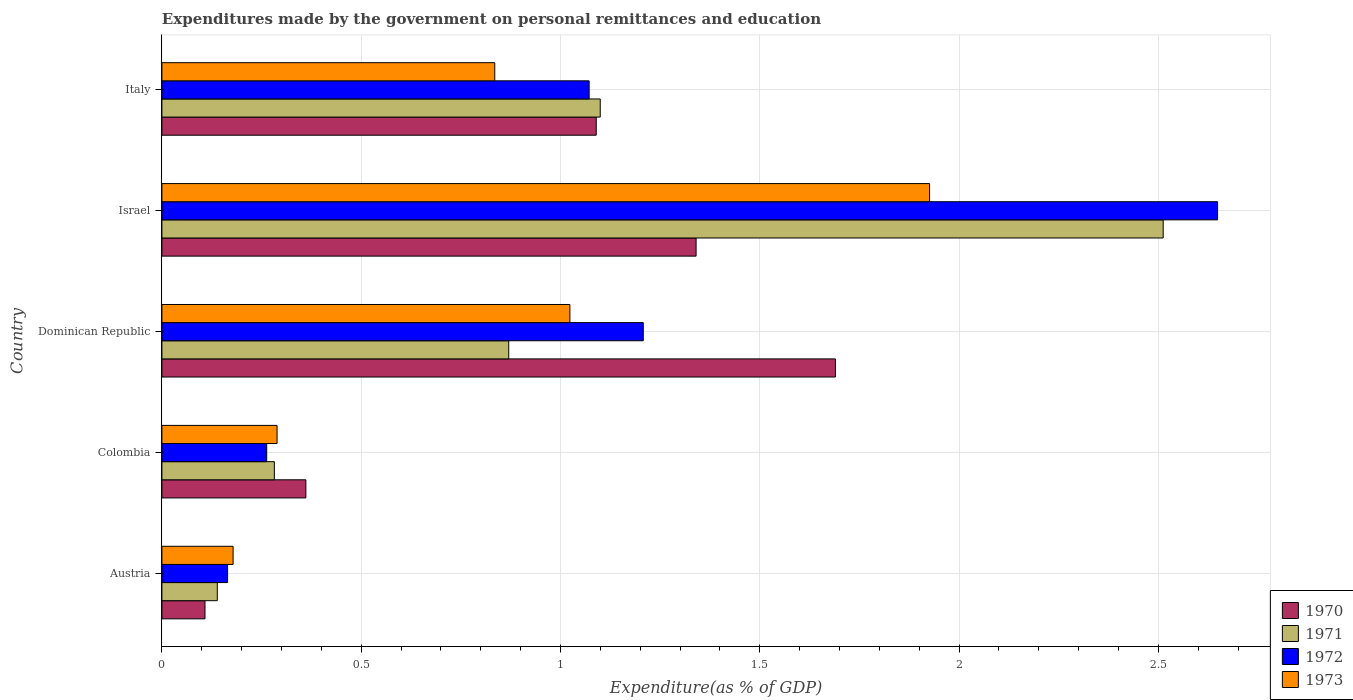How many different coloured bars are there?
Provide a short and direct response. 4. Are the number of bars on each tick of the Y-axis equal?
Keep it short and to the point. Yes. How many bars are there on the 1st tick from the bottom?
Offer a terse response. 4. What is the label of the 1st group of bars from the top?
Your response must be concise. Italy. In how many cases, is the number of bars for a given country not equal to the number of legend labels?
Offer a very short reply. 0. What is the expenditures made by the government on personal remittances and education in 1971 in Dominican Republic?
Give a very brief answer. 0.87. Across all countries, what is the maximum expenditures made by the government on personal remittances and education in 1973?
Make the answer very short. 1.93. Across all countries, what is the minimum expenditures made by the government on personal remittances and education in 1972?
Provide a succinct answer. 0.16. In which country was the expenditures made by the government on personal remittances and education in 1970 minimum?
Provide a succinct answer. Austria. What is the total expenditures made by the government on personal remittances and education in 1973 in the graph?
Offer a terse response. 4.25. What is the difference between the expenditures made by the government on personal remittances and education in 1972 in Colombia and that in Dominican Republic?
Your response must be concise. -0.94. What is the difference between the expenditures made by the government on personal remittances and education in 1972 in Italy and the expenditures made by the government on personal remittances and education in 1973 in Austria?
Offer a terse response. 0.89. What is the average expenditures made by the government on personal remittances and education in 1972 per country?
Make the answer very short. 1.07. What is the difference between the expenditures made by the government on personal remittances and education in 1971 and expenditures made by the government on personal remittances and education in 1972 in Austria?
Offer a terse response. -0.03. What is the ratio of the expenditures made by the government on personal remittances and education in 1973 in Colombia to that in Dominican Republic?
Offer a very short reply. 0.28. Is the difference between the expenditures made by the government on personal remittances and education in 1971 in Austria and Israel greater than the difference between the expenditures made by the government on personal remittances and education in 1972 in Austria and Israel?
Ensure brevity in your answer.  Yes. What is the difference between the highest and the second highest expenditures made by the government on personal remittances and education in 1970?
Provide a succinct answer. 0.35. What is the difference between the highest and the lowest expenditures made by the government on personal remittances and education in 1971?
Give a very brief answer. 2.37. In how many countries, is the expenditures made by the government on personal remittances and education in 1973 greater than the average expenditures made by the government on personal remittances and education in 1973 taken over all countries?
Offer a terse response. 2. Is the sum of the expenditures made by the government on personal remittances and education in 1972 in Austria and Dominican Republic greater than the maximum expenditures made by the government on personal remittances and education in 1973 across all countries?
Your answer should be very brief. No. What does the 4th bar from the top in Austria represents?
Give a very brief answer. 1970. Is it the case that in every country, the sum of the expenditures made by the government on personal remittances and education in 1972 and expenditures made by the government on personal remittances and education in 1971 is greater than the expenditures made by the government on personal remittances and education in 1973?
Make the answer very short. Yes. How many bars are there?
Your answer should be compact. 20. What is the difference between two consecutive major ticks on the X-axis?
Keep it short and to the point. 0.5. Does the graph contain any zero values?
Ensure brevity in your answer.  No. Where does the legend appear in the graph?
Offer a very short reply. Bottom right. How are the legend labels stacked?
Your answer should be very brief. Vertical. What is the title of the graph?
Offer a very short reply. Expenditures made by the government on personal remittances and education. What is the label or title of the X-axis?
Provide a short and direct response. Expenditure(as % of GDP). What is the label or title of the Y-axis?
Provide a short and direct response. Country. What is the Expenditure(as % of GDP) of 1970 in Austria?
Offer a very short reply. 0.11. What is the Expenditure(as % of GDP) in 1971 in Austria?
Offer a very short reply. 0.14. What is the Expenditure(as % of GDP) in 1972 in Austria?
Offer a very short reply. 0.16. What is the Expenditure(as % of GDP) of 1973 in Austria?
Keep it short and to the point. 0.18. What is the Expenditure(as % of GDP) of 1970 in Colombia?
Ensure brevity in your answer.  0.36. What is the Expenditure(as % of GDP) in 1971 in Colombia?
Offer a very short reply. 0.28. What is the Expenditure(as % of GDP) in 1972 in Colombia?
Your answer should be very brief. 0.26. What is the Expenditure(as % of GDP) in 1973 in Colombia?
Your answer should be compact. 0.29. What is the Expenditure(as % of GDP) of 1970 in Dominican Republic?
Provide a succinct answer. 1.69. What is the Expenditure(as % of GDP) in 1971 in Dominican Republic?
Offer a terse response. 0.87. What is the Expenditure(as % of GDP) of 1972 in Dominican Republic?
Your answer should be very brief. 1.21. What is the Expenditure(as % of GDP) in 1973 in Dominican Republic?
Your answer should be compact. 1.02. What is the Expenditure(as % of GDP) of 1970 in Israel?
Ensure brevity in your answer.  1.34. What is the Expenditure(as % of GDP) of 1971 in Israel?
Make the answer very short. 2.51. What is the Expenditure(as % of GDP) in 1972 in Israel?
Offer a terse response. 2.65. What is the Expenditure(as % of GDP) in 1973 in Israel?
Ensure brevity in your answer.  1.93. What is the Expenditure(as % of GDP) in 1970 in Italy?
Give a very brief answer. 1.09. What is the Expenditure(as % of GDP) in 1971 in Italy?
Ensure brevity in your answer.  1.1. What is the Expenditure(as % of GDP) in 1972 in Italy?
Your response must be concise. 1.07. What is the Expenditure(as % of GDP) of 1973 in Italy?
Offer a terse response. 0.84. Across all countries, what is the maximum Expenditure(as % of GDP) of 1970?
Give a very brief answer. 1.69. Across all countries, what is the maximum Expenditure(as % of GDP) in 1971?
Provide a short and direct response. 2.51. Across all countries, what is the maximum Expenditure(as % of GDP) in 1972?
Your answer should be compact. 2.65. Across all countries, what is the maximum Expenditure(as % of GDP) of 1973?
Your response must be concise. 1.93. Across all countries, what is the minimum Expenditure(as % of GDP) in 1970?
Keep it short and to the point. 0.11. Across all countries, what is the minimum Expenditure(as % of GDP) of 1971?
Give a very brief answer. 0.14. Across all countries, what is the minimum Expenditure(as % of GDP) of 1972?
Offer a very short reply. 0.16. Across all countries, what is the minimum Expenditure(as % of GDP) of 1973?
Offer a very short reply. 0.18. What is the total Expenditure(as % of GDP) in 1970 in the graph?
Offer a terse response. 4.59. What is the total Expenditure(as % of GDP) in 1971 in the graph?
Offer a terse response. 4.9. What is the total Expenditure(as % of GDP) in 1972 in the graph?
Give a very brief answer. 5.36. What is the total Expenditure(as % of GDP) of 1973 in the graph?
Keep it short and to the point. 4.25. What is the difference between the Expenditure(as % of GDP) of 1970 in Austria and that in Colombia?
Your answer should be very brief. -0.25. What is the difference between the Expenditure(as % of GDP) in 1971 in Austria and that in Colombia?
Provide a short and direct response. -0.14. What is the difference between the Expenditure(as % of GDP) in 1972 in Austria and that in Colombia?
Keep it short and to the point. -0.1. What is the difference between the Expenditure(as % of GDP) of 1973 in Austria and that in Colombia?
Provide a succinct answer. -0.11. What is the difference between the Expenditure(as % of GDP) in 1970 in Austria and that in Dominican Republic?
Offer a terse response. -1.58. What is the difference between the Expenditure(as % of GDP) of 1971 in Austria and that in Dominican Republic?
Give a very brief answer. -0.73. What is the difference between the Expenditure(as % of GDP) of 1972 in Austria and that in Dominican Republic?
Keep it short and to the point. -1.04. What is the difference between the Expenditure(as % of GDP) of 1973 in Austria and that in Dominican Republic?
Your answer should be compact. -0.84. What is the difference between the Expenditure(as % of GDP) in 1970 in Austria and that in Israel?
Keep it short and to the point. -1.23. What is the difference between the Expenditure(as % of GDP) in 1971 in Austria and that in Israel?
Offer a terse response. -2.37. What is the difference between the Expenditure(as % of GDP) of 1972 in Austria and that in Israel?
Provide a short and direct response. -2.48. What is the difference between the Expenditure(as % of GDP) of 1973 in Austria and that in Israel?
Your answer should be compact. -1.75. What is the difference between the Expenditure(as % of GDP) in 1970 in Austria and that in Italy?
Your answer should be compact. -0.98. What is the difference between the Expenditure(as % of GDP) in 1971 in Austria and that in Italy?
Offer a terse response. -0.96. What is the difference between the Expenditure(as % of GDP) of 1972 in Austria and that in Italy?
Ensure brevity in your answer.  -0.91. What is the difference between the Expenditure(as % of GDP) of 1973 in Austria and that in Italy?
Offer a terse response. -0.66. What is the difference between the Expenditure(as % of GDP) in 1970 in Colombia and that in Dominican Republic?
Keep it short and to the point. -1.33. What is the difference between the Expenditure(as % of GDP) of 1971 in Colombia and that in Dominican Republic?
Offer a very short reply. -0.59. What is the difference between the Expenditure(as % of GDP) in 1972 in Colombia and that in Dominican Republic?
Your response must be concise. -0.94. What is the difference between the Expenditure(as % of GDP) of 1973 in Colombia and that in Dominican Republic?
Offer a very short reply. -0.73. What is the difference between the Expenditure(as % of GDP) of 1970 in Colombia and that in Israel?
Provide a short and direct response. -0.98. What is the difference between the Expenditure(as % of GDP) in 1971 in Colombia and that in Israel?
Your response must be concise. -2.23. What is the difference between the Expenditure(as % of GDP) in 1972 in Colombia and that in Israel?
Offer a terse response. -2.39. What is the difference between the Expenditure(as % of GDP) in 1973 in Colombia and that in Israel?
Provide a succinct answer. -1.64. What is the difference between the Expenditure(as % of GDP) in 1970 in Colombia and that in Italy?
Your answer should be very brief. -0.73. What is the difference between the Expenditure(as % of GDP) in 1971 in Colombia and that in Italy?
Give a very brief answer. -0.82. What is the difference between the Expenditure(as % of GDP) of 1972 in Colombia and that in Italy?
Your answer should be compact. -0.81. What is the difference between the Expenditure(as % of GDP) in 1973 in Colombia and that in Italy?
Offer a terse response. -0.55. What is the difference between the Expenditure(as % of GDP) of 1970 in Dominican Republic and that in Israel?
Offer a very short reply. 0.35. What is the difference between the Expenditure(as % of GDP) in 1971 in Dominican Republic and that in Israel?
Make the answer very short. -1.64. What is the difference between the Expenditure(as % of GDP) of 1972 in Dominican Republic and that in Israel?
Keep it short and to the point. -1.44. What is the difference between the Expenditure(as % of GDP) of 1973 in Dominican Republic and that in Israel?
Provide a succinct answer. -0.9. What is the difference between the Expenditure(as % of GDP) of 1970 in Dominican Republic and that in Italy?
Offer a terse response. 0.6. What is the difference between the Expenditure(as % of GDP) of 1971 in Dominican Republic and that in Italy?
Your answer should be compact. -0.23. What is the difference between the Expenditure(as % of GDP) of 1972 in Dominican Republic and that in Italy?
Provide a succinct answer. 0.14. What is the difference between the Expenditure(as % of GDP) in 1973 in Dominican Republic and that in Italy?
Give a very brief answer. 0.19. What is the difference between the Expenditure(as % of GDP) in 1970 in Israel and that in Italy?
Offer a very short reply. 0.25. What is the difference between the Expenditure(as % of GDP) in 1971 in Israel and that in Italy?
Ensure brevity in your answer.  1.41. What is the difference between the Expenditure(as % of GDP) in 1972 in Israel and that in Italy?
Offer a terse response. 1.58. What is the difference between the Expenditure(as % of GDP) of 1973 in Israel and that in Italy?
Offer a terse response. 1.09. What is the difference between the Expenditure(as % of GDP) of 1970 in Austria and the Expenditure(as % of GDP) of 1971 in Colombia?
Provide a succinct answer. -0.17. What is the difference between the Expenditure(as % of GDP) of 1970 in Austria and the Expenditure(as % of GDP) of 1972 in Colombia?
Offer a terse response. -0.15. What is the difference between the Expenditure(as % of GDP) in 1970 in Austria and the Expenditure(as % of GDP) in 1973 in Colombia?
Your response must be concise. -0.18. What is the difference between the Expenditure(as % of GDP) in 1971 in Austria and the Expenditure(as % of GDP) in 1972 in Colombia?
Offer a terse response. -0.12. What is the difference between the Expenditure(as % of GDP) in 1971 in Austria and the Expenditure(as % of GDP) in 1973 in Colombia?
Give a very brief answer. -0.15. What is the difference between the Expenditure(as % of GDP) of 1972 in Austria and the Expenditure(as % of GDP) of 1973 in Colombia?
Offer a very short reply. -0.12. What is the difference between the Expenditure(as % of GDP) in 1970 in Austria and the Expenditure(as % of GDP) in 1971 in Dominican Republic?
Give a very brief answer. -0.76. What is the difference between the Expenditure(as % of GDP) in 1970 in Austria and the Expenditure(as % of GDP) in 1972 in Dominican Republic?
Your answer should be compact. -1.1. What is the difference between the Expenditure(as % of GDP) of 1970 in Austria and the Expenditure(as % of GDP) of 1973 in Dominican Republic?
Your answer should be very brief. -0.92. What is the difference between the Expenditure(as % of GDP) in 1971 in Austria and the Expenditure(as % of GDP) in 1972 in Dominican Republic?
Offer a very short reply. -1.07. What is the difference between the Expenditure(as % of GDP) of 1971 in Austria and the Expenditure(as % of GDP) of 1973 in Dominican Republic?
Give a very brief answer. -0.88. What is the difference between the Expenditure(as % of GDP) in 1972 in Austria and the Expenditure(as % of GDP) in 1973 in Dominican Republic?
Offer a very short reply. -0.86. What is the difference between the Expenditure(as % of GDP) in 1970 in Austria and the Expenditure(as % of GDP) in 1971 in Israel?
Your answer should be very brief. -2.4. What is the difference between the Expenditure(as % of GDP) in 1970 in Austria and the Expenditure(as % of GDP) in 1972 in Israel?
Give a very brief answer. -2.54. What is the difference between the Expenditure(as % of GDP) in 1970 in Austria and the Expenditure(as % of GDP) in 1973 in Israel?
Ensure brevity in your answer.  -1.82. What is the difference between the Expenditure(as % of GDP) of 1971 in Austria and the Expenditure(as % of GDP) of 1972 in Israel?
Your answer should be very brief. -2.51. What is the difference between the Expenditure(as % of GDP) in 1971 in Austria and the Expenditure(as % of GDP) in 1973 in Israel?
Your response must be concise. -1.79. What is the difference between the Expenditure(as % of GDP) in 1972 in Austria and the Expenditure(as % of GDP) in 1973 in Israel?
Give a very brief answer. -1.76. What is the difference between the Expenditure(as % of GDP) of 1970 in Austria and the Expenditure(as % of GDP) of 1971 in Italy?
Your answer should be very brief. -0.99. What is the difference between the Expenditure(as % of GDP) of 1970 in Austria and the Expenditure(as % of GDP) of 1972 in Italy?
Ensure brevity in your answer.  -0.96. What is the difference between the Expenditure(as % of GDP) of 1970 in Austria and the Expenditure(as % of GDP) of 1973 in Italy?
Make the answer very short. -0.73. What is the difference between the Expenditure(as % of GDP) in 1971 in Austria and the Expenditure(as % of GDP) in 1972 in Italy?
Your answer should be compact. -0.93. What is the difference between the Expenditure(as % of GDP) in 1971 in Austria and the Expenditure(as % of GDP) in 1973 in Italy?
Give a very brief answer. -0.7. What is the difference between the Expenditure(as % of GDP) of 1972 in Austria and the Expenditure(as % of GDP) of 1973 in Italy?
Offer a terse response. -0.67. What is the difference between the Expenditure(as % of GDP) in 1970 in Colombia and the Expenditure(as % of GDP) in 1971 in Dominican Republic?
Your answer should be very brief. -0.51. What is the difference between the Expenditure(as % of GDP) of 1970 in Colombia and the Expenditure(as % of GDP) of 1972 in Dominican Republic?
Offer a very short reply. -0.85. What is the difference between the Expenditure(as % of GDP) of 1970 in Colombia and the Expenditure(as % of GDP) of 1973 in Dominican Republic?
Your answer should be compact. -0.66. What is the difference between the Expenditure(as % of GDP) of 1971 in Colombia and the Expenditure(as % of GDP) of 1972 in Dominican Republic?
Ensure brevity in your answer.  -0.93. What is the difference between the Expenditure(as % of GDP) of 1971 in Colombia and the Expenditure(as % of GDP) of 1973 in Dominican Republic?
Provide a short and direct response. -0.74. What is the difference between the Expenditure(as % of GDP) in 1972 in Colombia and the Expenditure(as % of GDP) in 1973 in Dominican Republic?
Your response must be concise. -0.76. What is the difference between the Expenditure(as % of GDP) of 1970 in Colombia and the Expenditure(as % of GDP) of 1971 in Israel?
Give a very brief answer. -2.15. What is the difference between the Expenditure(as % of GDP) in 1970 in Colombia and the Expenditure(as % of GDP) in 1972 in Israel?
Your answer should be very brief. -2.29. What is the difference between the Expenditure(as % of GDP) in 1970 in Colombia and the Expenditure(as % of GDP) in 1973 in Israel?
Provide a short and direct response. -1.56. What is the difference between the Expenditure(as % of GDP) of 1971 in Colombia and the Expenditure(as % of GDP) of 1972 in Israel?
Your answer should be compact. -2.37. What is the difference between the Expenditure(as % of GDP) in 1971 in Colombia and the Expenditure(as % of GDP) in 1973 in Israel?
Ensure brevity in your answer.  -1.64. What is the difference between the Expenditure(as % of GDP) of 1972 in Colombia and the Expenditure(as % of GDP) of 1973 in Israel?
Ensure brevity in your answer.  -1.66. What is the difference between the Expenditure(as % of GDP) in 1970 in Colombia and the Expenditure(as % of GDP) in 1971 in Italy?
Your answer should be very brief. -0.74. What is the difference between the Expenditure(as % of GDP) of 1970 in Colombia and the Expenditure(as % of GDP) of 1972 in Italy?
Your answer should be compact. -0.71. What is the difference between the Expenditure(as % of GDP) of 1970 in Colombia and the Expenditure(as % of GDP) of 1973 in Italy?
Your response must be concise. -0.47. What is the difference between the Expenditure(as % of GDP) of 1971 in Colombia and the Expenditure(as % of GDP) of 1972 in Italy?
Provide a short and direct response. -0.79. What is the difference between the Expenditure(as % of GDP) in 1971 in Colombia and the Expenditure(as % of GDP) in 1973 in Italy?
Offer a very short reply. -0.55. What is the difference between the Expenditure(as % of GDP) in 1972 in Colombia and the Expenditure(as % of GDP) in 1973 in Italy?
Provide a succinct answer. -0.57. What is the difference between the Expenditure(as % of GDP) of 1970 in Dominican Republic and the Expenditure(as % of GDP) of 1971 in Israel?
Give a very brief answer. -0.82. What is the difference between the Expenditure(as % of GDP) of 1970 in Dominican Republic and the Expenditure(as % of GDP) of 1972 in Israel?
Your answer should be very brief. -0.96. What is the difference between the Expenditure(as % of GDP) in 1970 in Dominican Republic and the Expenditure(as % of GDP) in 1973 in Israel?
Your response must be concise. -0.24. What is the difference between the Expenditure(as % of GDP) of 1971 in Dominican Republic and the Expenditure(as % of GDP) of 1972 in Israel?
Your answer should be very brief. -1.78. What is the difference between the Expenditure(as % of GDP) in 1971 in Dominican Republic and the Expenditure(as % of GDP) in 1973 in Israel?
Keep it short and to the point. -1.06. What is the difference between the Expenditure(as % of GDP) in 1972 in Dominican Republic and the Expenditure(as % of GDP) in 1973 in Israel?
Keep it short and to the point. -0.72. What is the difference between the Expenditure(as % of GDP) of 1970 in Dominican Republic and the Expenditure(as % of GDP) of 1971 in Italy?
Make the answer very short. 0.59. What is the difference between the Expenditure(as % of GDP) of 1970 in Dominican Republic and the Expenditure(as % of GDP) of 1972 in Italy?
Offer a very short reply. 0.62. What is the difference between the Expenditure(as % of GDP) of 1970 in Dominican Republic and the Expenditure(as % of GDP) of 1973 in Italy?
Make the answer very short. 0.85. What is the difference between the Expenditure(as % of GDP) of 1971 in Dominican Republic and the Expenditure(as % of GDP) of 1972 in Italy?
Your answer should be compact. -0.2. What is the difference between the Expenditure(as % of GDP) of 1971 in Dominican Republic and the Expenditure(as % of GDP) of 1973 in Italy?
Provide a succinct answer. 0.04. What is the difference between the Expenditure(as % of GDP) of 1972 in Dominican Republic and the Expenditure(as % of GDP) of 1973 in Italy?
Keep it short and to the point. 0.37. What is the difference between the Expenditure(as % of GDP) of 1970 in Israel and the Expenditure(as % of GDP) of 1971 in Italy?
Make the answer very short. 0.24. What is the difference between the Expenditure(as % of GDP) in 1970 in Israel and the Expenditure(as % of GDP) in 1972 in Italy?
Your response must be concise. 0.27. What is the difference between the Expenditure(as % of GDP) of 1970 in Israel and the Expenditure(as % of GDP) of 1973 in Italy?
Your response must be concise. 0.51. What is the difference between the Expenditure(as % of GDP) in 1971 in Israel and the Expenditure(as % of GDP) in 1972 in Italy?
Provide a succinct answer. 1.44. What is the difference between the Expenditure(as % of GDP) in 1971 in Israel and the Expenditure(as % of GDP) in 1973 in Italy?
Your answer should be compact. 1.68. What is the difference between the Expenditure(as % of GDP) of 1972 in Israel and the Expenditure(as % of GDP) of 1973 in Italy?
Provide a short and direct response. 1.81. What is the average Expenditure(as % of GDP) of 1970 per country?
Give a very brief answer. 0.92. What is the average Expenditure(as % of GDP) in 1971 per country?
Provide a succinct answer. 0.98. What is the average Expenditure(as % of GDP) of 1972 per country?
Your answer should be very brief. 1.07. What is the average Expenditure(as % of GDP) in 1973 per country?
Offer a terse response. 0.85. What is the difference between the Expenditure(as % of GDP) of 1970 and Expenditure(as % of GDP) of 1971 in Austria?
Make the answer very short. -0.03. What is the difference between the Expenditure(as % of GDP) of 1970 and Expenditure(as % of GDP) of 1972 in Austria?
Your response must be concise. -0.06. What is the difference between the Expenditure(as % of GDP) in 1970 and Expenditure(as % of GDP) in 1973 in Austria?
Give a very brief answer. -0.07. What is the difference between the Expenditure(as % of GDP) of 1971 and Expenditure(as % of GDP) of 1972 in Austria?
Give a very brief answer. -0.03. What is the difference between the Expenditure(as % of GDP) of 1971 and Expenditure(as % of GDP) of 1973 in Austria?
Keep it short and to the point. -0.04. What is the difference between the Expenditure(as % of GDP) of 1972 and Expenditure(as % of GDP) of 1973 in Austria?
Keep it short and to the point. -0.01. What is the difference between the Expenditure(as % of GDP) in 1970 and Expenditure(as % of GDP) in 1971 in Colombia?
Ensure brevity in your answer.  0.08. What is the difference between the Expenditure(as % of GDP) in 1970 and Expenditure(as % of GDP) in 1972 in Colombia?
Keep it short and to the point. 0.1. What is the difference between the Expenditure(as % of GDP) of 1970 and Expenditure(as % of GDP) of 1973 in Colombia?
Your response must be concise. 0.07. What is the difference between the Expenditure(as % of GDP) of 1971 and Expenditure(as % of GDP) of 1972 in Colombia?
Provide a short and direct response. 0.02. What is the difference between the Expenditure(as % of GDP) in 1971 and Expenditure(as % of GDP) in 1973 in Colombia?
Your answer should be compact. -0.01. What is the difference between the Expenditure(as % of GDP) of 1972 and Expenditure(as % of GDP) of 1973 in Colombia?
Provide a succinct answer. -0.03. What is the difference between the Expenditure(as % of GDP) in 1970 and Expenditure(as % of GDP) in 1971 in Dominican Republic?
Give a very brief answer. 0.82. What is the difference between the Expenditure(as % of GDP) in 1970 and Expenditure(as % of GDP) in 1972 in Dominican Republic?
Your answer should be very brief. 0.48. What is the difference between the Expenditure(as % of GDP) in 1970 and Expenditure(as % of GDP) in 1973 in Dominican Republic?
Give a very brief answer. 0.67. What is the difference between the Expenditure(as % of GDP) in 1971 and Expenditure(as % of GDP) in 1972 in Dominican Republic?
Keep it short and to the point. -0.34. What is the difference between the Expenditure(as % of GDP) in 1971 and Expenditure(as % of GDP) in 1973 in Dominican Republic?
Your answer should be compact. -0.15. What is the difference between the Expenditure(as % of GDP) of 1972 and Expenditure(as % of GDP) of 1973 in Dominican Republic?
Ensure brevity in your answer.  0.18. What is the difference between the Expenditure(as % of GDP) of 1970 and Expenditure(as % of GDP) of 1971 in Israel?
Provide a succinct answer. -1.17. What is the difference between the Expenditure(as % of GDP) of 1970 and Expenditure(as % of GDP) of 1972 in Israel?
Keep it short and to the point. -1.31. What is the difference between the Expenditure(as % of GDP) in 1970 and Expenditure(as % of GDP) in 1973 in Israel?
Provide a short and direct response. -0.59. What is the difference between the Expenditure(as % of GDP) in 1971 and Expenditure(as % of GDP) in 1972 in Israel?
Provide a succinct answer. -0.14. What is the difference between the Expenditure(as % of GDP) in 1971 and Expenditure(as % of GDP) in 1973 in Israel?
Give a very brief answer. 0.59. What is the difference between the Expenditure(as % of GDP) of 1972 and Expenditure(as % of GDP) of 1973 in Israel?
Your answer should be very brief. 0.72. What is the difference between the Expenditure(as % of GDP) in 1970 and Expenditure(as % of GDP) in 1971 in Italy?
Your answer should be compact. -0.01. What is the difference between the Expenditure(as % of GDP) in 1970 and Expenditure(as % of GDP) in 1972 in Italy?
Keep it short and to the point. 0.02. What is the difference between the Expenditure(as % of GDP) in 1970 and Expenditure(as % of GDP) in 1973 in Italy?
Ensure brevity in your answer.  0.25. What is the difference between the Expenditure(as % of GDP) in 1971 and Expenditure(as % of GDP) in 1972 in Italy?
Your answer should be very brief. 0.03. What is the difference between the Expenditure(as % of GDP) of 1971 and Expenditure(as % of GDP) of 1973 in Italy?
Give a very brief answer. 0.26. What is the difference between the Expenditure(as % of GDP) of 1972 and Expenditure(as % of GDP) of 1973 in Italy?
Offer a very short reply. 0.24. What is the ratio of the Expenditure(as % of GDP) in 1970 in Austria to that in Colombia?
Provide a short and direct response. 0.3. What is the ratio of the Expenditure(as % of GDP) of 1971 in Austria to that in Colombia?
Keep it short and to the point. 0.49. What is the ratio of the Expenditure(as % of GDP) in 1972 in Austria to that in Colombia?
Provide a short and direct response. 0.63. What is the ratio of the Expenditure(as % of GDP) of 1973 in Austria to that in Colombia?
Provide a short and direct response. 0.62. What is the ratio of the Expenditure(as % of GDP) of 1970 in Austria to that in Dominican Republic?
Provide a short and direct response. 0.06. What is the ratio of the Expenditure(as % of GDP) of 1971 in Austria to that in Dominican Republic?
Your answer should be very brief. 0.16. What is the ratio of the Expenditure(as % of GDP) of 1972 in Austria to that in Dominican Republic?
Provide a succinct answer. 0.14. What is the ratio of the Expenditure(as % of GDP) in 1973 in Austria to that in Dominican Republic?
Provide a succinct answer. 0.17. What is the ratio of the Expenditure(as % of GDP) of 1970 in Austria to that in Israel?
Your answer should be compact. 0.08. What is the ratio of the Expenditure(as % of GDP) in 1971 in Austria to that in Israel?
Offer a terse response. 0.06. What is the ratio of the Expenditure(as % of GDP) in 1972 in Austria to that in Israel?
Your answer should be compact. 0.06. What is the ratio of the Expenditure(as % of GDP) of 1973 in Austria to that in Israel?
Offer a very short reply. 0.09. What is the ratio of the Expenditure(as % of GDP) of 1970 in Austria to that in Italy?
Provide a short and direct response. 0.1. What is the ratio of the Expenditure(as % of GDP) of 1971 in Austria to that in Italy?
Make the answer very short. 0.13. What is the ratio of the Expenditure(as % of GDP) in 1972 in Austria to that in Italy?
Offer a very short reply. 0.15. What is the ratio of the Expenditure(as % of GDP) of 1973 in Austria to that in Italy?
Your answer should be very brief. 0.21. What is the ratio of the Expenditure(as % of GDP) of 1970 in Colombia to that in Dominican Republic?
Provide a succinct answer. 0.21. What is the ratio of the Expenditure(as % of GDP) in 1971 in Colombia to that in Dominican Republic?
Keep it short and to the point. 0.32. What is the ratio of the Expenditure(as % of GDP) in 1972 in Colombia to that in Dominican Republic?
Provide a short and direct response. 0.22. What is the ratio of the Expenditure(as % of GDP) in 1973 in Colombia to that in Dominican Republic?
Offer a very short reply. 0.28. What is the ratio of the Expenditure(as % of GDP) in 1970 in Colombia to that in Israel?
Provide a short and direct response. 0.27. What is the ratio of the Expenditure(as % of GDP) in 1971 in Colombia to that in Israel?
Your answer should be compact. 0.11. What is the ratio of the Expenditure(as % of GDP) of 1972 in Colombia to that in Israel?
Provide a short and direct response. 0.1. What is the ratio of the Expenditure(as % of GDP) of 1970 in Colombia to that in Italy?
Provide a short and direct response. 0.33. What is the ratio of the Expenditure(as % of GDP) of 1971 in Colombia to that in Italy?
Make the answer very short. 0.26. What is the ratio of the Expenditure(as % of GDP) in 1972 in Colombia to that in Italy?
Your answer should be compact. 0.25. What is the ratio of the Expenditure(as % of GDP) of 1973 in Colombia to that in Italy?
Your answer should be compact. 0.35. What is the ratio of the Expenditure(as % of GDP) in 1970 in Dominican Republic to that in Israel?
Ensure brevity in your answer.  1.26. What is the ratio of the Expenditure(as % of GDP) in 1971 in Dominican Republic to that in Israel?
Provide a short and direct response. 0.35. What is the ratio of the Expenditure(as % of GDP) of 1972 in Dominican Republic to that in Israel?
Your answer should be compact. 0.46. What is the ratio of the Expenditure(as % of GDP) in 1973 in Dominican Republic to that in Israel?
Make the answer very short. 0.53. What is the ratio of the Expenditure(as % of GDP) of 1970 in Dominican Republic to that in Italy?
Ensure brevity in your answer.  1.55. What is the ratio of the Expenditure(as % of GDP) of 1971 in Dominican Republic to that in Italy?
Give a very brief answer. 0.79. What is the ratio of the Expenditure(as % of GDP) of 1972 in Dominican Republic to that in Italy?
Make the answer very short. 1.13. What is the ratio of the Expenditure(as % of GDP) of 1973 in Dominican Republic to that in Italy?
Give a very brief answer. 1.23. What is the ratio of the Expenditure(as % of GDP) of 1970 in Israel to that in Italy?
Provide a succinct answer. 1.23. What is the ratio of the Expenditure(as % of GDP) of 1971 in Israel to that in Italy?
Offer a very short reply. 2.28. What is the ratio of the Expenditure(as % of GDP) in 1972 in Israel to that in Italy?
Your answer should be compact. 2.47. What is the ratio of the Expenditure(as % of GDP) of 1973 in Israel to that in Italy?
Your answer should be compact. 2.31. What is the difference between the highest and the second highest Expenditure(as % of GDP) of 1970?
Offer a terse response. 0.35. What is the difference between the highest and the second highest Expenditure(as % of GDP) in 1971?
Ensure brevity in your answer.  1.41. What is the difference between the highest and the second highest Expenditure(as % of GDP) in 1972?
Keep it short and to the point. 1.44. What is the difference between the highest and the second highest Expenditure(as % of GDP) of 1973?
Offer a terse response. 0.9. What is the difference between the highest and the lowest Expenditure(as % of GDP) in 1970?
Provide a short and direct response. 1.58. What is the difference between the highest and the lowest Expenditure(as % of GDP) in 1971?
Your answer should be compact. 2.37. What is the difference between the highest and the lowest Expenditure(as % of GDP) of 1972?
Offer a very short reply. 2.48. What is the difference between the highest and the lowest Expenditure(as % of GDP) in 1973?
Provide a succinct answer. 1.75. 